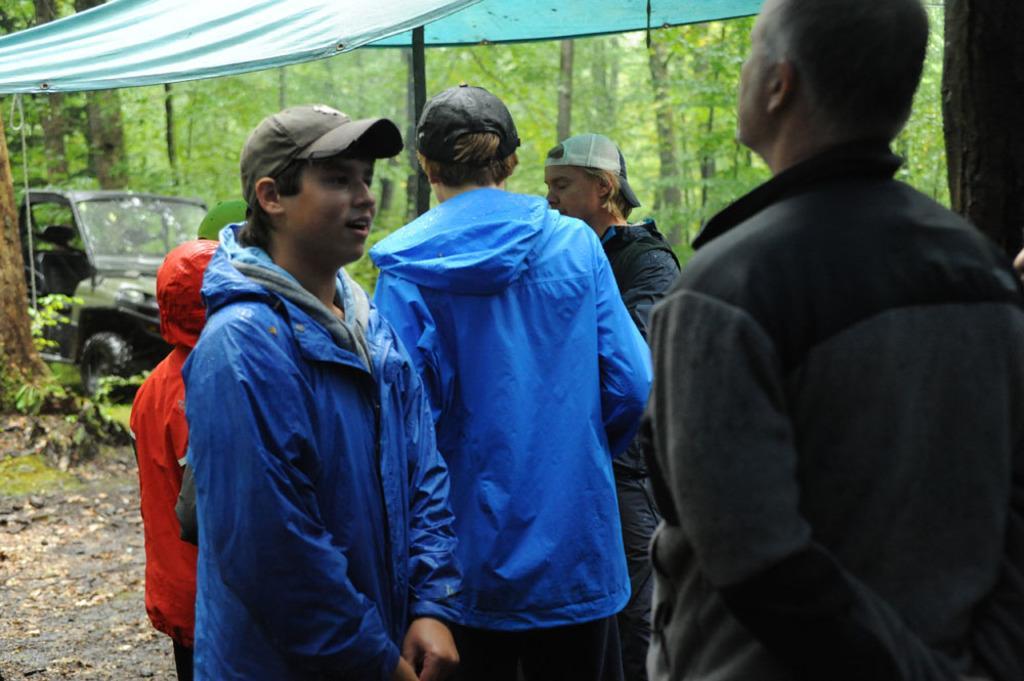Describe this image in one or two sentences. In this picture we can see a group of people on the ground, here we can see a vehicle, tent and in the background we can see trees. 